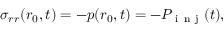Convert formula to latex. <formula><loc_0><loc_0><loc_500><loc_500>\sigma _ { r r } ( r _ { 0 } , t ) = - p ( r _ { 0 } , t ) = - P _ { i n j } ( t ) ,</formula> 